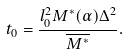<formula> <loc_0><loc_0><loc_500><loc_500>t _ { 0 } = \frac { l _ { 0 } ^ { 2 } M ^ { \ast } ( \alpha ) \Delta ^ { 2 } } { \overline { M ^ { \ast } } } .</formula> 